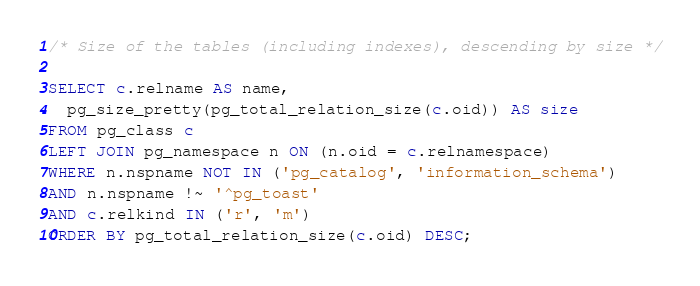Convert code to text. <code><loc_0><loc_0><loc_500><loc_500><_SQL_>/* Size of the tables (including indexes), descending by size */

SELECT c.relname AS name,
  pg_size_pretty(pg_total_relation_size(c.oid)) AS size
FROM pg_class c
LEFT JOIN pg_namespace n ON (n.oid = c.relnamespace)
WHERE n.nspname NOT IN ('pg_catalog', 'information_schema')
AND n.nspname !~ '^pg_toast'
AND c.relkind IN ('r', 'm')
ORDER BY pg_total_relation_size(c.oid) DESC;
</code> 